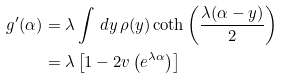Convert formula to latex. <formula><loc_0><loc_0><loc_500><loc_500>g ^ { \prime } ( \alpha ) & = \lambda \int \, d y \, \rho ( y ) \coth \left ( \frac { \lambda ( \alpha - y ) } { 2 } \right ) \\ & = \lambda \left [ 1 - 2 v \left ( e ^ { \lambda \alpha } \right ) \right ]</formula> 